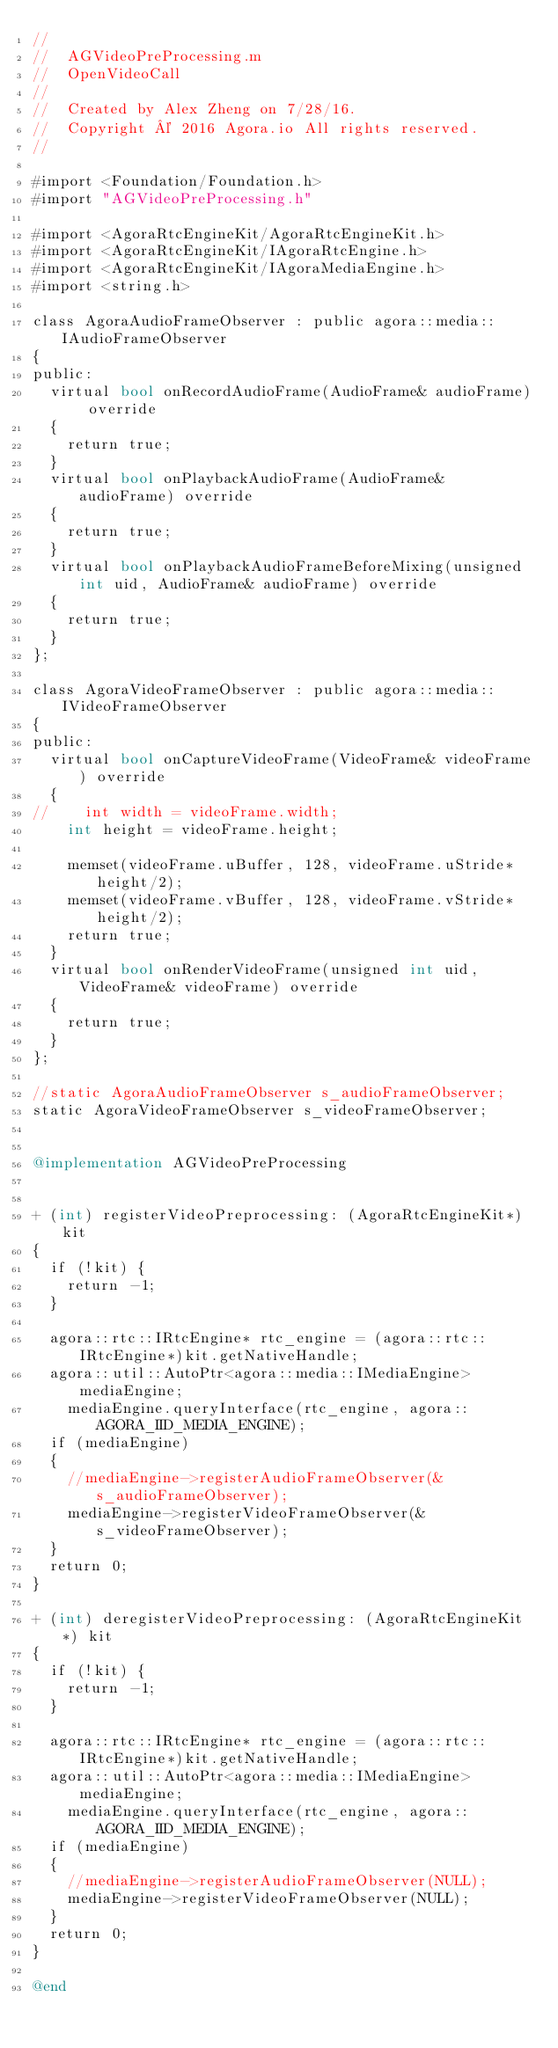<code> <loc_0><loc_0><loc_500><loc_500><_ObjectiveC_>//
//  AGVideoPreProcessing.m
//  OpenVideoCall
//
//  Created by Alex Zheng on 7/28/16.
//  Copyright © 2016 Agora.io All rights reserved.
//

#import <Foundation/Foundation.h>
#import "AGVideoPreProcessing.h"

#import <AgoraRtcEngineKit/AgoraRtcEngineKit.h>
#import <AgoraRtcEngineKit/IAgoraRtcEngine.h>
#import <AgoraRtcEngineKit/IAgoraMediaEngine.h>
#import <string.h>

class AgoraAudioFrameObserver : public agora::media::IAudioFrameObserver
{
public:
  virtual bool onRecordAudioFrame(AudioFrame& audioFrame) override
  {
    return true;
  }
  virtual bool onPlaybackAudioFrame(AudioFrame& audioFrame) override
  {
    return true;
  }
  virtual bool onPlaybackAudioFrameBeforeMixing(unsigned int uid, AudioFrame& audioFrame) override
  {
    return true;
  }
};

class AgoraVideoFrameObserver : public agora::media::IVideoFrameObserver
{
public:
  virtual bool onCaptureVideoFrame(VideoFrame& videoFrame) override
  {
//    int width = videoFrame.width;
    int height = videoFrame.height;
    
    memset(videoFrame.uBuffer, 128, videoFrame.uStride*height/2);
    memset(videoFrame.vBuffer, 128, videoFrame.vStride*height/2);
    return true;
  }
  virtual bool onRenderVideoFrame(unsigned int uid, VideoFrame& videoFrame) override
  {
    return true;
  }
};

//static AgoraAudioFrameObserver s_audioFrameObserver;
static AgoraVideoFrameObserver s_videoFrameObserver;


@implementation AGVideoPreProcessing


+ (int) registerVideoPreprocessing: (AgoraRtcEngineKit*) kit
{
  if (!kit) {
    return -1;
  }
  
  agora::rtc::IRtcEngine* rtc_engine = (agora::rtc::IRtcEngine*)kit.getNativeHandle;
  agora::util::AutoPtr<agora::media::IMediaEngine> mediaEngine;
    mediaEngine.queryInterface(rtc_engine, agora::AGORA_IID_MEDIA_ENGINE);
  if (mediaEngine)
  {
    //mediaEngine->registerAudioFrameObserver(&s_audioFrameObserver);
    mediaEngine->registerVideoFrameObserver(&s_videoFrameObserver);
  }
  return 0;
}

+ (int) deregisterVideoPreprocessing: (AgoraRtcEngineKit*) kit
{
  if (!kit) {
    return -1;
  }
  
  agora::rtc::IRtcEngine* rtc_engine = (agora::rtc::IRtcEngine*)kit.getNativeHandle;
  agora::util::AutoPtr<agora::media::IMediaEngine> mediaEngine;
    mediaEngine.queryInterface(rtc_engine, agora::AGORA_IID_MEDIA_ENGINE);
  if (mediaEngine)
  {
    //mediaEngine->registerAudioFrameObserver(NULL);
    mediaEngine->registerVideoFrameObserver(NULL);
  }
  return 0;
}

@end
</code> 